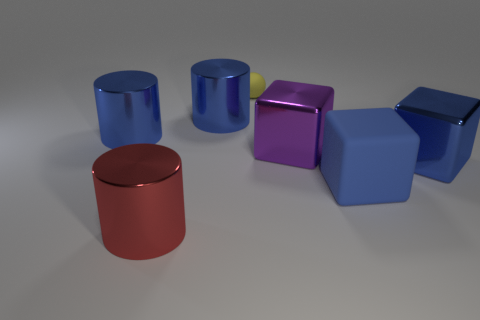Does the cylinder in front of the large purple shiny block have the same size as the matte thing to the right of the yellow ball?
Make the answer very short. Yes. There is a cylinder that is in front of the big blue shiny object that is in front of the purple block; are there any big purple cubes that are in front of it?
Provide a succinct answer. No. Are there fewer blue metal objects that are to the right of the large red shiny cylinder than objects behind the purple object?
Provide a succinct answer. Yes. What is the shape of the big thing that is made of the same material as the small ball?
Ensure brevity in your answer.  Cube. There is a rubber thing left of the large blue cube to the left of the large blue thing on the right side of the large matte object; what is its size?
Offer a terse response. Small. Are there more purple things than blue cubes?
Provide a succinct answer. No. There is a shiny cube in front of the purple cube; does it have the same color as the matte object that is in front of the large purple block?
Provide a succinct answer. Yes. Does the large blue thing that is left of the big red cylinder have the same material as the tiny yellow object that is right of the red thing?
Your answer should be very brief. No. How many rubber things are the same size as the blue shiny cube?
Offer a very short reply. 1. Are there fewer shiny things than large things?
Offer a terse response. Yes. 